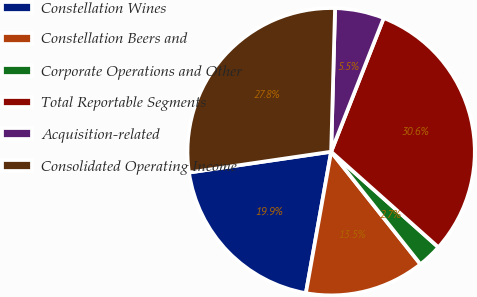<chart> <loc_0><loc_0><loc_500><loc_500><pie_chart><fcel>Constellation Wines<fcel>Constellation Beers and<fcel>Corporate Operations and Other<fcel>Total Reportable Segments<fcel>Acquisition-related<fcel>Consolidated Operating Income<nl><fcel>19.87%<fcel>13.49%<fcel>2.74%<fcel>30.62%<fcel>5.53%<fcel>27.75%<nl></chart> 